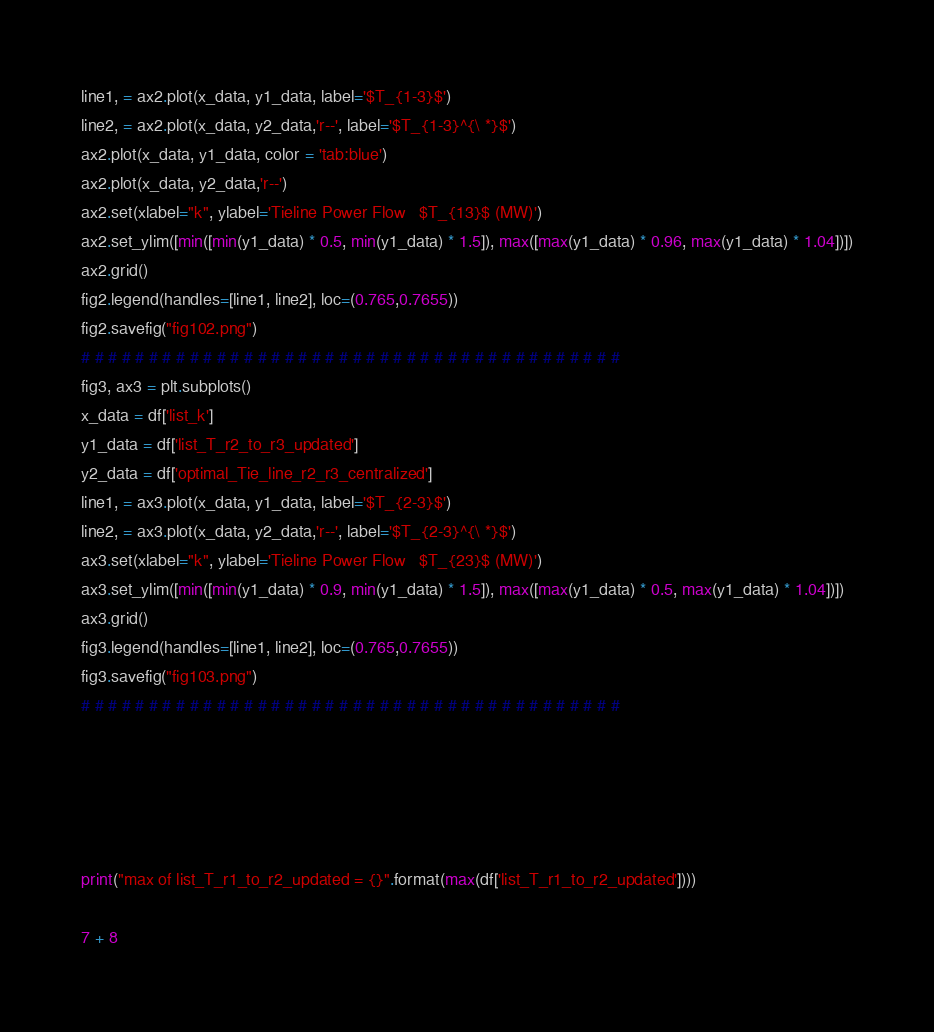Convert code to text. <code><loc_0><loc_0><loc_500><loc_500><_Python_>line1, = ax2.plot(x_data, y1_data, label='$T_{1-3}$')
line2, = ax2.plot(x_data, y2_data,'r--', label='$T_{1-3}^{\ *}$')
ax2.plot(x_data, y1_data, color = 'tab:blue')
ax2.plot(x_data, y2_data,'r--')
ax2.set(xlabel="k", ylabel='Tieline Power Flow   $T_{13}$ (MW)')
ax2.set_ylim([min([min(y1_data) * 0.5, min(y1_data) * 1.5]), max([max(y1_data) * 0.96, max(y1_data) * 1.04])])
ax2.grid()
fig2.legend(handles=[line1, line2], loc=(0.765,0.7655))
fig2.savefig("fig102.png")
# # # # # # # # # # # # # # # # # # # # # # # # # # # # # # # # # # # # # # # #
fig3, ax3 = plt.subplots()
x_data = df['list_k']
y1_data = df['list_T_r2_to_r3_updated']
y2_data = df['optimal_Tie_line_r2_r3_centralized']
line1, = ax3.plot(x_data, y1_data, label='$T_{2-3}$')
line2, = ax3.plot(x_data, y2_data,'r--', label='$T_{2-3}^{\ *}$')
ax3.set(xlabel="k", ylabel='Tieline Power Flow   $T_{23}$ (MW)')
ax3.set_ylim([min([min(y1_data) * 0.9, min(y1_data) * 1.5]), max([max(y1_data) * 0.5, max(y1_data) * 1.04])])
ax3.grid()
fig3.legend(handles=[line1, line2], loc=(0.765,0.7655))
fig3.savefig("fig103.png")
# # # # # # # # # # # # # # # # # # # # # # # # # # # # # # # # # # # # # # # #





print("max of list_T_r1_to_r2_updated = {}".format(max(df['list_T_r1_to_r2_updated'])))

7 + 8
</code> 